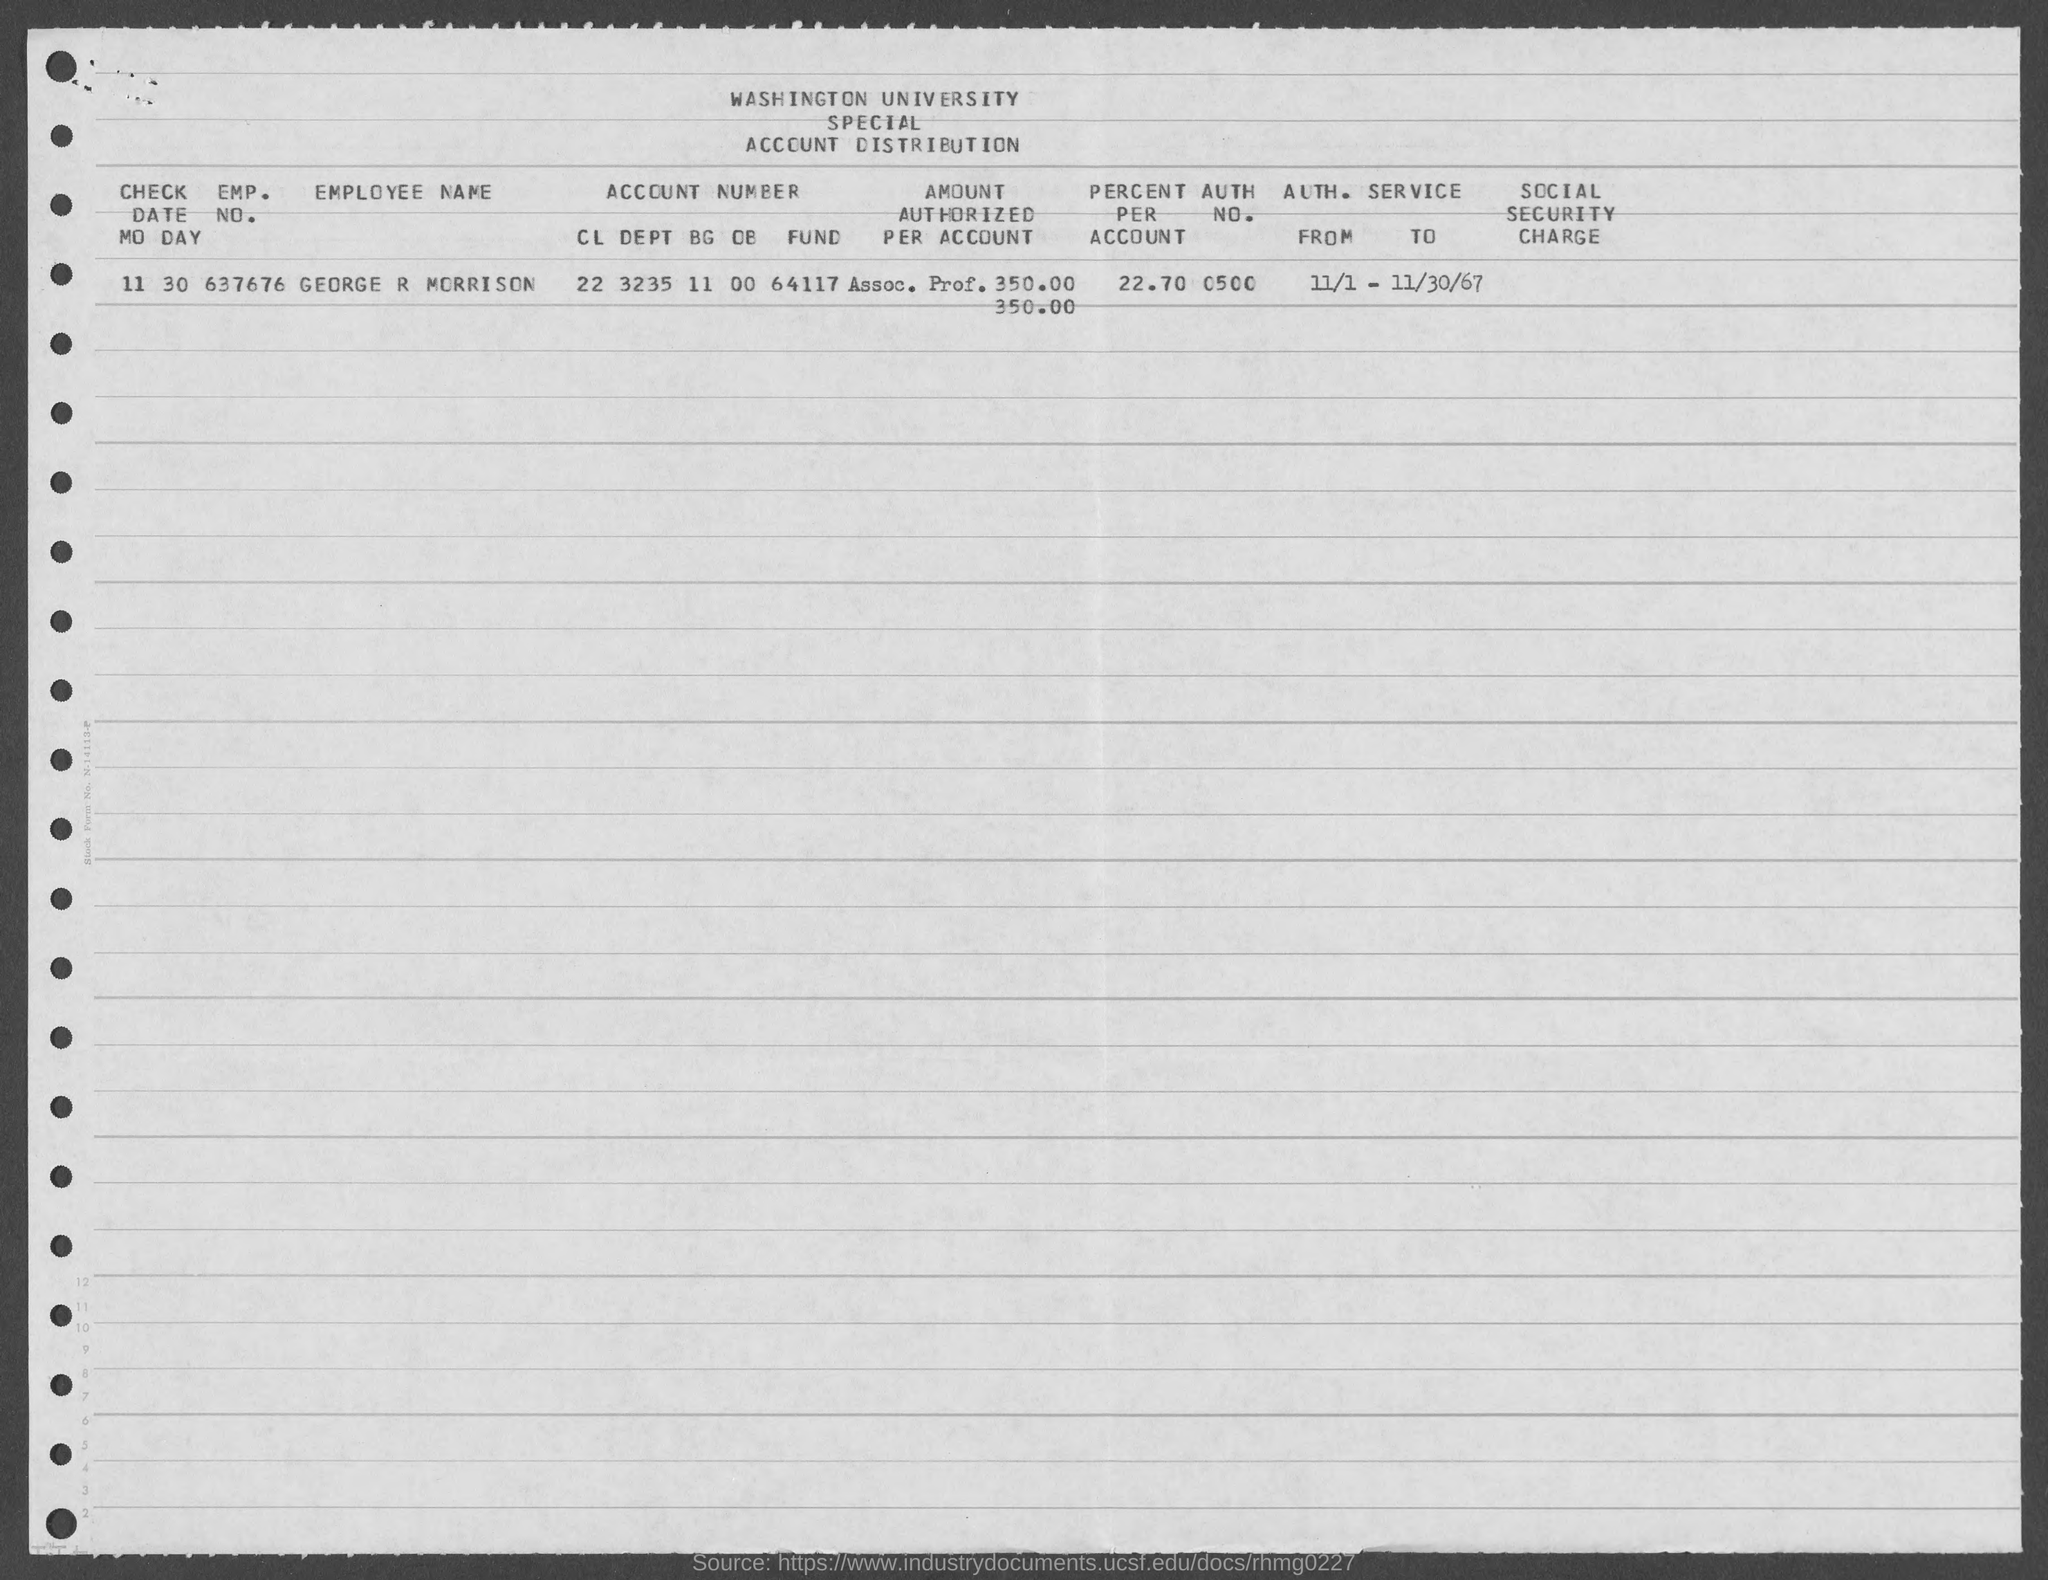What is the name of the university mentioned in the given form ?
Keep it short and to the point. WASHINGTON UNIVERSITY. What is the auth. no. mentioned in the given form ?
Give a very brief answer. 0500. What is the value of percent per account as mentioned in the given form ?
Offer a very short reply. 22 70. What is the check date mentioned in the given form ?
Your answer should be compact. 11 30. What is the emp. no. mentioned in the given form ?
Provide a short and direct response. 637676. What is the employee name mentioned in the given form ?
Offer a terse response. George r morrison. What is the account number mentioned in the given form ?
Your response must be concise. 22 3235 11 00 64117. 